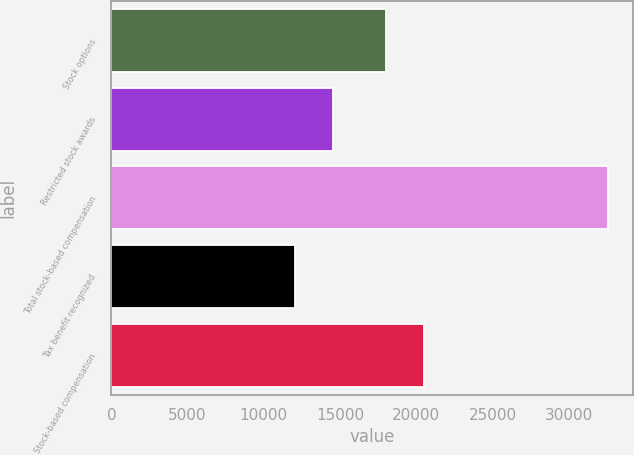Convert chart to OTSL. <chart><loc_0><loc_0><loc_500><loc_500><bar_chart><fcel>Stock options<fcel>Restricted stock awards<fcel>Total stock-based compensation<fcel>Tax benefit recognized<fcel>Stock-based compensation<nl><fcel>18025<fcel>14533<fcel>32558<fcel>12028<fcel>20530<nl></chart> 